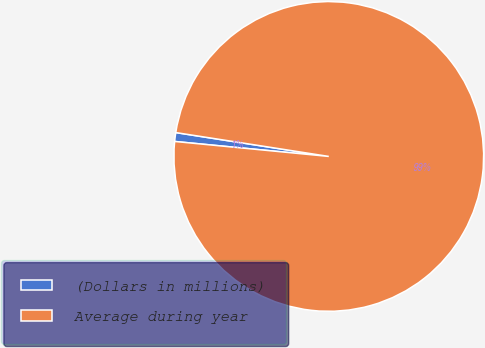<chart> <loc_0><loc_0><loc_500><loc_500><pie_chart><fcel>(Dollars in millions)<fcel>Average during year<nl><fcel>0.92%<fcel>99.08%<nl></chart> 